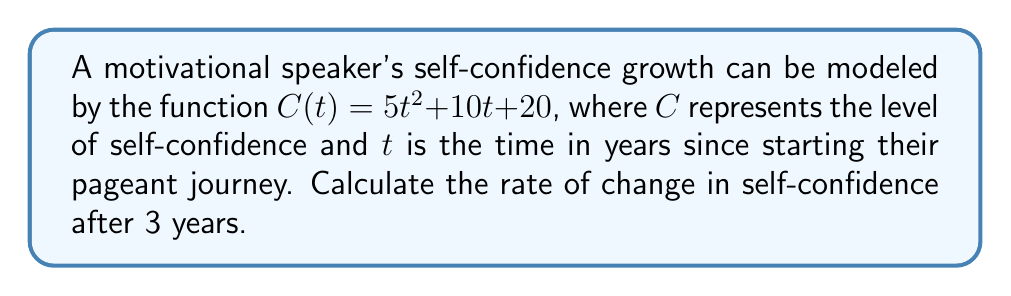Can you solve this math problem? To find the rate of change in self-confidence, we need to calculate the derivative of the given function and evaluate it at $t = 3$.

1. The given function is $C(t) = 5t^2 + 10t + 20$

2. To find the derivative, we use the power rule and constant rule:
   $\frac{d}{dt}(5t^2) = 5 \cdot 2t = 10t$
   $\frac{d}{dt}(10t) = 10$
   $\frac{d}{dt}(20) = 0$

3. Combining these results, we get the derivative:
   $C'(t) = 10t + 10$

4. Now, we evaluate $C'(t)$ at $t = 3$:
   $C'(3) = 10(3) + 10 = 30 + 10 = 40$

Therefore, the rate of change in self-confidence after 3 years is 40 units per year.
Answer: 40 units per year 